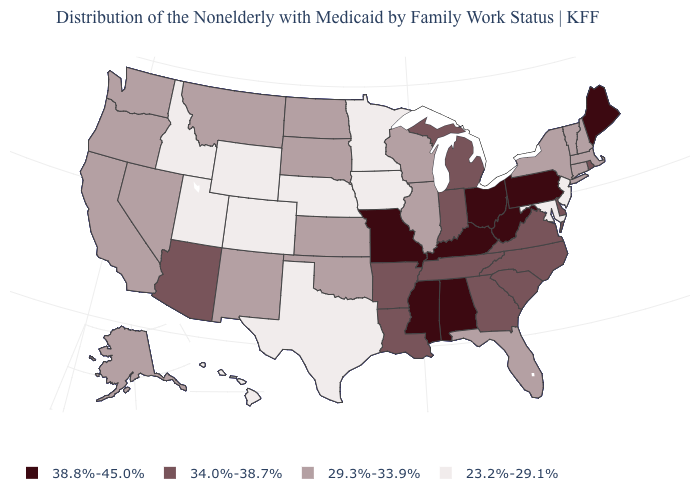Does Louisiana have a higher value than Florida?
Be succinct. Yes. Does the first symbol in the legend represent the smallest category?
Write a very short answer. No. How many symbols are there in the legend?
Answer briefly. 4. What is the value of Idaho?
Answer briefly. 23.2%-29.1%. What is the value of Alabama?
Answer briefly. 38.8%-45.0%. What is the value of Vermont?
Be succinct. 29.3%-33.9%. Which states have the lowest value in the West?
Answer briefly. Colorado, Hawaii, Idaho, Utah, Wyoming. What is the value of Louisiana?
Be succinct. 34.0%-38.7%. Which states hav the highest value in the Northeast?
Write a very short answer. Maine, Pennsylvania. What is the lowest value in the Northeast?
Quick response, please. 23.2%-29.1%. What is the value of Massachusetts?
Be succinct. 29.3%-33.9%. Name the states that have a value in the range 34.0%-38.7%?
Write a very short answer. Arizona, Arkansas, Delaware, Georgia, Indiana, Louisiana, Michigan, North Carolina, Rhode Island, South Carolina, Tennessee, Virginia. What is the lowest value in the USA?
Short answer required. 23.2%-29.1%. Name the states that have a value in the range 38.8%-45.0%?
Short answer required. Alabama, Kentucky, Maine, Mississippi, Missouri, Ohio, Pennsylvania, West Virginia. 